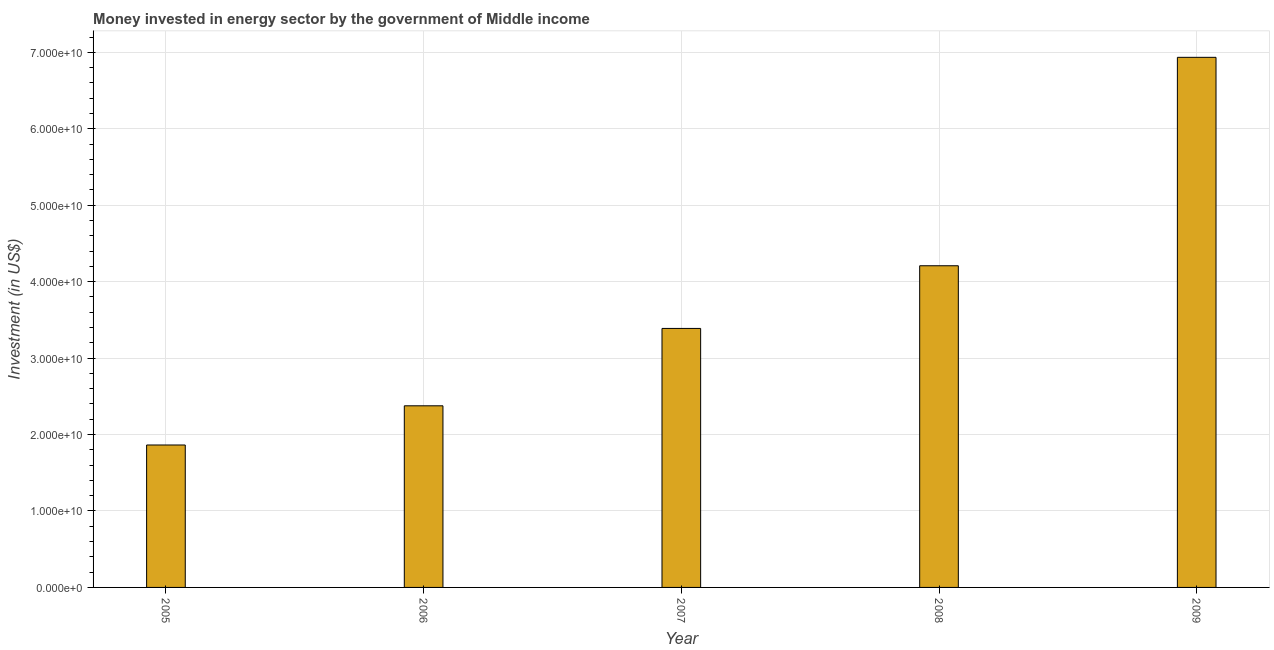What is the title of the graph?
Offer a terse response. Money invested in energy sector by the government of Middle income. What is the label or title of the X-axis?
Ensure brevity in your answer.  Year. What is the label or title of the Y-axis?
Offer a very short reply. Investment (in US$). What is the investment in energy in 2007?
Offer a very short reply. 3.39e+1. Across all years, what is the maximum investment in energy?
Provide a short and direct response. 6.94e+1. Across all years, what is the minimum investment in energy?
Provide a short and direct response. 1.86e+1. In which year was the investment in energy minimum?
Offer a terse response. 2005. What is the sum of the investment in energy?
Your response must be concise. 1.88e+11. What is the difference between the investment in energy in 2006 and 2008?
Offer a very short reply. -1.83e+1. What is the average investment in energy per year?
Make the answer very short. 3.75e+1. What is the median investment in energy?
Offer a very short reply. 3.39e+1. Do a majority of the years between 2009 and 2005 (inclusive) have investment in energy greater than 52000000000 US$?
Your response must be concise. Yes. What is the ratio of the investment in energy in 2006 to that in 2009?
Offer a very short reply. 0.34. What is the difference between the highest and the second highest investment in energy?
Provide a short and direct response. 2.73e+1. Is the sum of the investment in energy in 2008 and 2009 greater than the maximum investment in energy across all years?
Offer a very short reply. Yes. What is the difference between the highest and the lowest investment in energy?
Provide a succinct answer. 5.07e+1. How many bars are there?
Provide a short and direct response. 5. Are all the bars in the graph horizontal?
Make the answer very short. No. What is the Investment (in US$) of 2005?
Your answer should be very brief. 1.86e+1. What is the Investment (in US$) of 2006?
Give a very brief answer. 2.38e+1. What is the Investment (in US$) in 2007?
Offer a terse response. 3.39e+1. What is the Investment (in US$) of 2008?
Offer a terse response. 4.21e+1. What is the Investment (in US$) of 2009?
Give a very brief answer. 6.94e+1. What is the difference between the Investment (in US$) in 2005 and 2006?
Make the answer very short. -5.13e+09. What is the difference between the Investment (in US$) in 2005 and 2007?
Offer a very short reply. -1.52e+1. What is the difference between the Investment (in US$) in 2005 and 2008?
Offer a terse response. -2.34e+1. What is the difference between the Investment (in US$) in 2005 and 2009?
Ensure brevity in your answer.  -5.07e+1. What is the difference between the Investment (in US$) in 2006 and 2007?
Offer a very short reply. -1.01e+1. What is the difference between the Investment (in US$) in 2006 and 2008?
Make the answer very short. -1.83e+1. What is the difference between the Investment (in US$) in 2006 and 2009?
Provide a short and direct response. -4.56e+1. What is the difference between the Investment (in US$) in 2007 and 2008?
Your answer should be compact. -8.20e+09. What is the difference between the Investment (in US$) in 2007 and 2009?
Ensure brevity in your answer.  -3.55e+1. What is the difference between the Investment (in US$) in 2008 and 2009?
Offer a very short reply. -2.73e+1. What is the ratio of the Investment (in US$) in 2005 to that in 2006?
Offer a very short reply. 0.78. What is the ratio of the Investment (in US$) in 2005 to that in 2007?
Ensure brevity in your answer.  0.55. What is the ratio of the Investment (in US$) in 2005 to that in 2008?
Give a very brief answer. 0.44. What is the ratio of the Investment (in US$) in 2005 to that in 2009?
Ensure brevity in your answer.  0.27. What is the ratio of the Investment (in US$) in 2006 to that in 2007?
Offer a very short reply. 0.7. What is the ratio of the Investment (in US$) in 2006 to that in 2008?
Your answer should be very brief. 0.56. What is the ratio of the Investment (in US$) in 2006 to that in 2009?
Your answer should be very brief. 0.34. What is the ratio of the Investment (in US$) in 2007 to that in 2008?
Give a very brief answer. 0.81. What is the ratio of the Investment (in US$) in 2007 to that in 2009?
Provide a succinct answer. 0.49. What is the ratio of the Investment (in US$) in 2008 to that in 2009?
Keep it short and to the point. 0.61. 